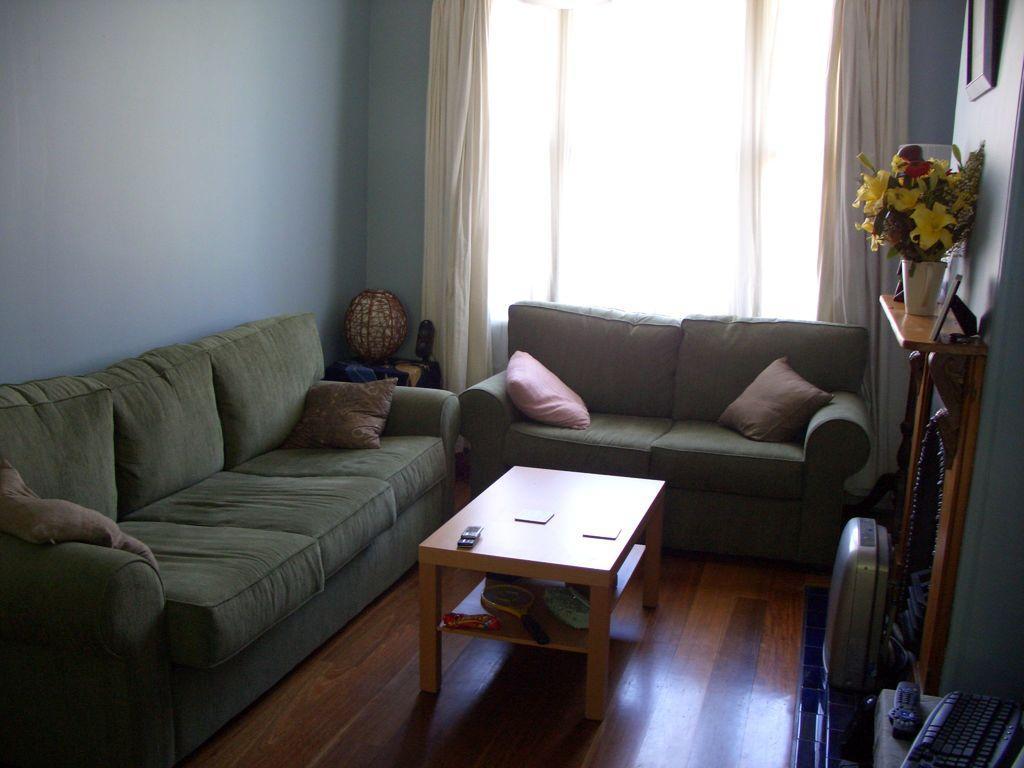How would you summarize this image in a sentence or two? In this room we can able to see couches with pillows. At the corner there is a table, on this table there is a decorative item. In-front of this cough there is a table, on this table there is a racket, mobile and things. On this furniture there is a plant and picture. At the right side of the image there is a table, On this table there is a remote and keyboard. This is window with curtain. A picture on wall. This floor is made with wood. 